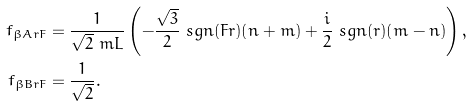<formula> <loc_0><loc_0><loc_500><loc_500>f _ { \beta A r F } & = \frac { 1 } { \sqrt { 2 } \ m L } \left ( - \frac { \sqrt { 3 } } { 2 } \ s g n ( F r ) ( n + m ) + \frac { i } { 2 } \ s g n ( r ) ( m - n ) \right ) , \\ f _ { \beta B r F } & = \frac { 1 } { \sqrt { 2 } } .</formula> 